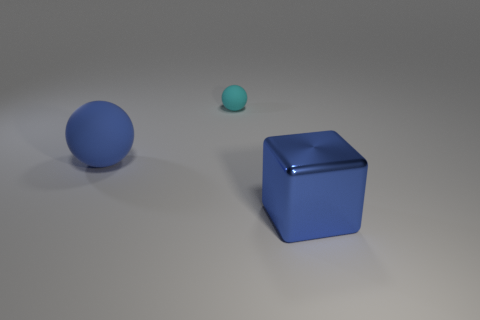Add 1 blue matte spheres. How many objects exist? 4 Subtract all spheres. How many objects are left? 1 Add 1 small cyan matte balls. How many small cyan matte balls are left? 2 Add 3 large brown cylinders. How many large brown cylinders exist? 3 Subtract 0 purple cylinders. How many objects are left? 3 Subtract all tiny metallic things. Subtract all rubber objects. How many objects are left? 1 